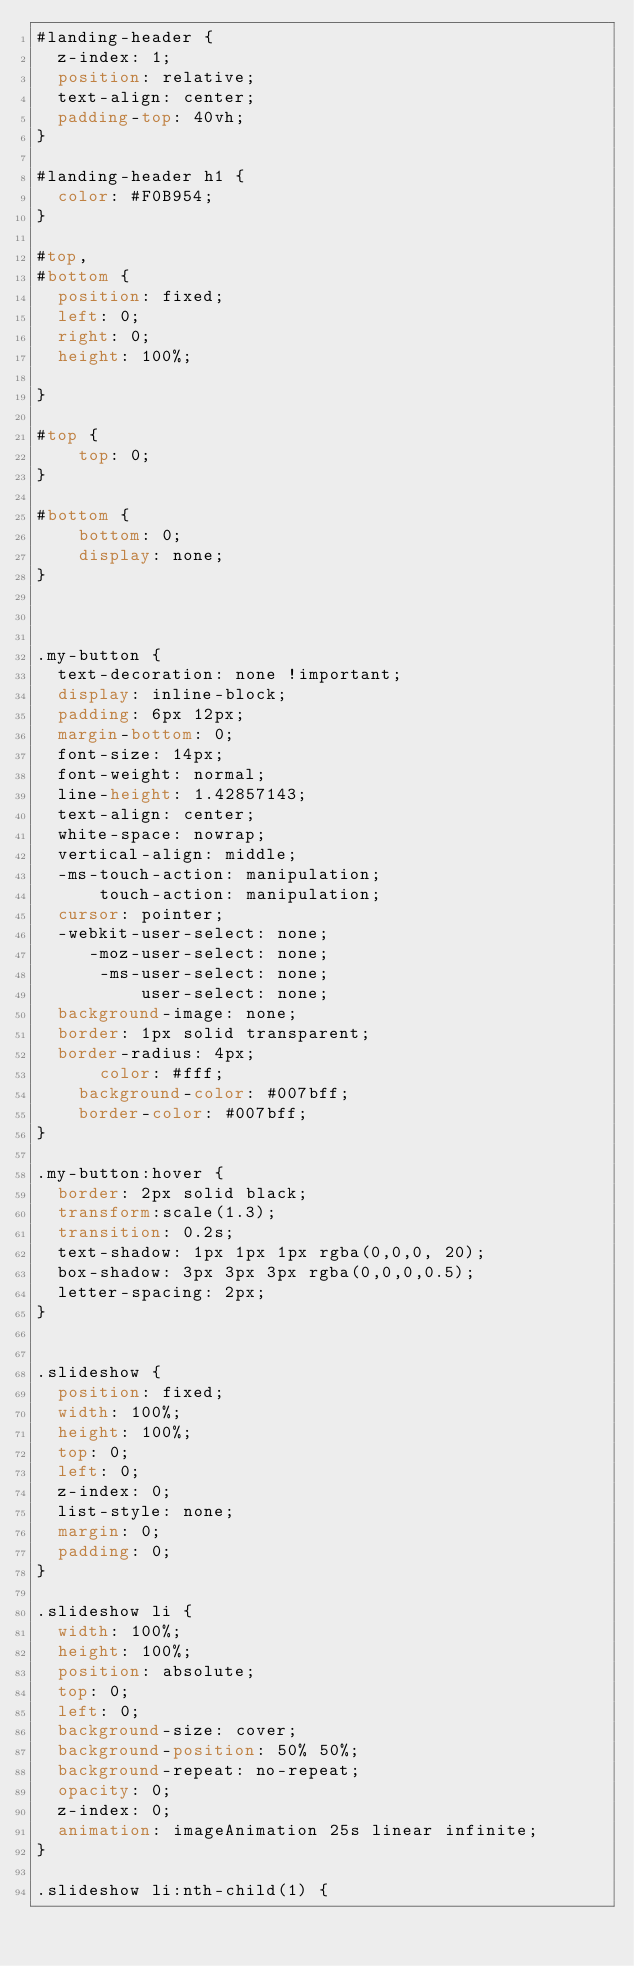<code> <loc_0><loc_0><loc_500><loc_500><_CSS_>#landing-header {
  z-index: 1;
  position: relative;
  text-align: center;
  padding-top: 40vh;
}

#landing-header h1 {
  color: #F0B954;
}

#top,
#bottom {
  position: fixed;
  left: 0;
  right: 0;
  height: 100%;
 
}

#top {
    top: 0;
}

#bottom {
    bottom: 0;
    display: none;
}



.my-button {
  text-decoration: none !important;
  display: inline-block;
  padding: 6px 12px;
  margin-bottom: 0;
  font-size: 14px;
  font-weight: normal;
  line-height: 1.42857143;
  text-align: center;
  white-space: nowrap;
  vertical-align: middle;
  -ms-touch-action: manipulation;
      touch-action: manipulation;
  cursor: pointer;
  -webkit-user-select: none;
     -moz-user-select: none;
      -ms-user-select: none;
          user-select: none;
  background-image: none;
  border: 1px solid transparent;
  border-radius: 4px;
      color: #fff;
    background-color: #007bff;
    border-color: #007bff;
}

.my-button:hover {
  border: 2px solid black;
  transform:scale(1.3);
  transition: 0.2s;
  text-shadow: 1px 1px 1px rgba(0,0,0, 20);
  box-shadow: 3px 3px 3px rgba(0,0,0,0.5);
  letter-spacing: 2px;
}


.slideshow { 
  position: fixed;
  width: 100%;
  height: 100%;
  top: 0;
  left: 0;
  z-index: 0;
  list-style: none;
  margin: 0;
  padding: 0;
}

.slideshow li { 
  width: 100%;
  height: 100%;
  position: absolute;
  top: 0;
  left: 0;
  background-size: cover;
  background-position: 50% 50%;
  background-repeat: no-repeat;
  opacity: 0;
  z-index: 0;
  animation: imageAnimation 25s linear infinite; 
}

.slideshow li:nth-child(1) { </code> 